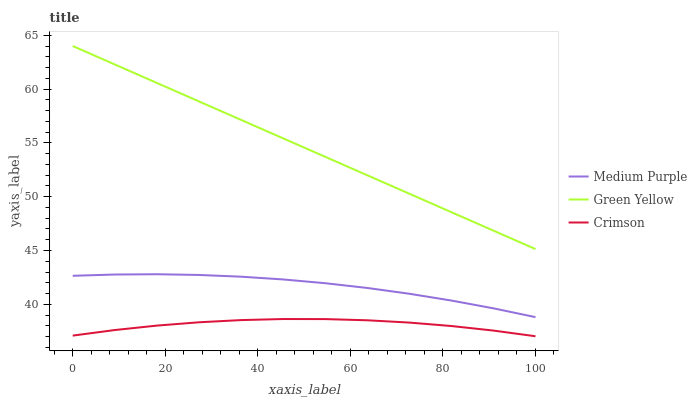Does Green Yellow have the minimum area under the curve?
Answer yes or no. No. Does Crimson have the maximum area under the curve?
Answer yes or no. No. Is Crimson the smoothest?
Answer yes or no. No. Is Green Yellow the roughest?
Answer yes or no. No. Does Green Yellow have the lowest value?
Answer yes or no. No. Does Crimson have the highest value?
Answer yes or no. No. Is Crimson less than Green Yellow?
Answer yes or no. Yes. Is Green Yellow greater than Crimson?
Answer yes or no. Yes. Does Crimson intersect Green Yellow?
Answer yes or no. No. 